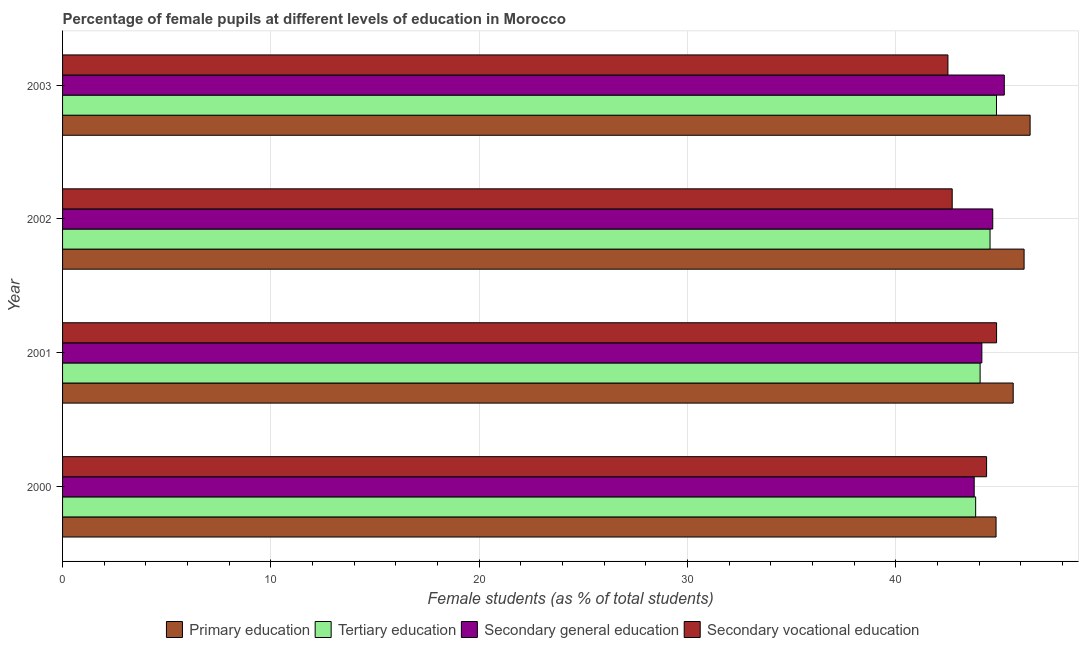How many different coloured bars are there?
Make the answer very short. 4. Are the number of bars on each tick of the Y-axis equal?
Ensure brevity in your answer.  Yes. How many bars are there on the 3rd tick from the top?
Make the answer very short. 4. How many bars are there on the 4th tick from the bottom?
Provide a succinct answer. 4. What is the label of the 2nd group of bars from the top?
Provide a succinct answer. 2002. In how many cases, is the number of bars for a given year not equal to the number of legend labels?
Give a very brief answer. 0. What is the percentage of female students in tertiary education in 2000?
Your answer should be compact. 43.83. Across all years, what is the maximum percentage of female students in tertiary education?
Make the answer very short. 44.83. Across all years, what is the minimum percentage of female students in secondary education?
Give a very brief answer. 43.76. In which year was the percentage of female students in secondary vocational education maximum?
Give a very brief answer. 2001. What is the total percentage of female students in primary education in the graph?
Your answer should be very brief. 183.03. What is the difference between the percentage of female students in primary education in 2000 and that in 2003?
Offer a terse response. -1.63. What is the difference between the percentage of female students in tertiary education in 2001 and the percentage of female students in primary education in 2002?
Give a very brief answer. -2.11. What is the average percentage of female students in tertiary education per year?
Offer a terse response. 44.3. In the year 2003, what is the difference between the percentage of female students in primary education and percentage of female students in secondary vocational education?
Your answer should be compact. 3.94. In how many years, is the percentage of female students in secondary vocational education greater than 42 %?
Offer a terse response. 4. What is the ratio of the percentage of female students in secondary education in 2000 to that in 2001?
Give a very brief answer. 0.99. Is the percentage of female students in tertiary education in 2001 less than that in 2003?
Your answer should be very brief. Yes. What is the difference between the highest and the second highest percentage of female students in primary education?
Keep it short and to the point. 0.29. Is it the case that in every year, the sum of the percentage of female students in secondary vocational education and percentage of female students in primary education is greater than the sum of percentage of female students in tertiary education and percentage of female students in secondary education?
Make the answer very short. No. What does the 3rd bar from the top in 2003 represents?
Give a very brief answer. Tertiary education. What does the 4th bar from the bottom in 2000 represents?
Offer a very short reply. Secondary vocational education. How many bars are there?
Provide a short and direct response. 16. Are all the bars in the graph horizontal?
Offer a very short reply. Yes. What is the difference between two consecutive major ticks on the X-axis?
Keep it short and to the point. 10. Does the graph contain any zero values?
Make the answer very short. No. Does the graph contain grids?
Your response must be concise. Yes. How many legend labels are there?
Offer a very short reply. 4. What is the title of the graph?
Your response must be concise. Percentage of female pupils at different levels of education in Morocco. What is the label or title of the X-axis?
Give a very brief answer. Female students (as % of total students). What is the label or title of the Y-axis?
Offer a very short reply. Year. What is the Female students (as % of total students) of Primary education in 2000?
Your answer should be very brief. 44.81. What is the Female students (as % of total students) of Tertiary education in 2000?
Offer a very short reply. 43.83. What is the Female students (as % of total students) in Secondary general education in 2000?
Offer a very short reply. 43.76. What is the Female students (as % of total students) of Secondary vocational education in 2000?
Your response must be concise. 44.35. What is the Female students (as % of total students) in Primary education in 2001?
Give a very brief answer. 45.63. What is the Female students (as % of total students) of Tertiary education in 2001?
Ensure brevity in your answer.  44.04. What is the Female students (as % of total students) in Secondary general education in 2001?
Give a very brief answer. 44.12. What is the Female students (as % of total students) in Secondary vocational education in 2001?
Provide a short and direct response. 44.83. What is the Female students (as % of total students) of Primary education in 2002?
Provide a short and direct response. 46.15. What is the Female students (as % of total students) of Tertiary education in 2002?
Your answer should be very brief. 44.52. What is the Female students (as % of total students) of Secondary general education in 2002?
Offer a very short reply. 44.65. What is the Female students (as % of total students) of Secondary vocational education in 2002?
Ensure brevity in your answer.  42.7. What is the Female students (as % of total students) of Primary education in 2003?
Make the answer very short. 46.44. What is the Female students (as % of total students) of Tertiary education in 2003?
Provide a succinct answer. 44.83. What is the Female students (as % of total students) of Secondary general education in 2003?
Provide a short and direct response. 45.2. What is the Female students (as % of total students) of Secondary vocational education in 2003?
Ensure brevity in your answer.  42.5. Across all years, what is the maximum Female students (as % of total students) of Primary education?
Provide a short and direct response. 46.44. Across all years, what is the maximum Female students (as % of total students) in Tertiary education?
Keep it short and to the point. 44.83. Across all years, what is the maximum Female students (as % of total students) of Secondary general education?
Your answer should be compact. 45.2. Across all years, what is the maximum Female students (as % of total students) in Secondary vocational education?
Offer a terse response. 44.83. Across all years, what is the minimum Female students (as % of total students) of Primary education?
Keep it short and to the point. 44.81. Across all years, what is the minimum Female students (as % of total students) of Tertiary education?
Keep it short and to the point. 43.83. Across all years, what is the minimum Female students (as % of total students) of Secondary general education?
Your answer should be very brief. 43.76. Across all years, what is the minimum Female students (as % of total students) in Secondary vocational education?
Offer a very short reply. 42.5. What is the total Female students (as % of total students) of Primary education in the graph?
Provide a succinct answer. 183.03. What is the total Female students (as % of total students) of Tertiary education in the graph?
Your answer should be very brief. 177.21. What is the total Female students (as % of total students) of Secondary general education in the graph?
Provide a short and direct response. 177.73. What is the total Female students (as % of total students) of Secondary vocational education in the graph?
Your response must be concise. 174.38. What is the difference between the Female students (as % of total students) in Primary education in 2000 and that in 2001?
Ensure brevity in your answer.  -0.82. What is the difference between the Female students (as % of total students) in Tertiary education in 2000 and that in 2001?
Make the answer very short. -0.21. What is the difference between the Female students (as % of total students) of Secondary general education in 2000 and that in 2001?
Your answer should be very brief. -0.37. What is the difference between the Female students (as % of total students) of Secondary vocational education in 2000 and that in 2001?
Your answer should be compact. -0.48. What is the difference between the Female students (as % of total students) in Primary education in 2000 and that in 2002?
Keep it short and to the point. -1.34. What is the difference between the Female students (as % of total students) of Tertiary education in 2000 and that in 2002?
Your answer should be very brief. -0.69. What is the difference between the Female students (as % of total students) of Secondary general education in 2000 and that in 2002?
Offer a very short reply. -0.89. What is the difference between the Female students (as % of total students) of Secondary vocational education in 2000 and that in 2002?
Make the answer very short. 1.65. What is the difference between the Female students (as % of total students) of Primary education in 2000 and that in 2003?
Provide a short and direct response. -1.63. What is the difference between the Female students (as % of total students) of Tertiary education in 2000 and that in 2003?
Keep it short and to the point. -1. What is the difference between the Female students (as % of total students) in Secondary general education in 2000 and that in 2003?
Give a very brief answer. -1.44. What is the difference between the Female students (as % of total students) of Secondary vocational education in 2000 and that in 2003?
Keep it short and to the point. 1.86. What is the difference between the Female students (as % of total students) of Primary education in 2001 and that in 2002?
Provide a short and direct response. -0.52. What is the difference between the Female students (as % of total students) of Tertiary education in 2001 and that in 2002?
Offer a terse response. -0.48. What is the difference between the Female students (as % of total students) of Secondary general education in 2001 and that in 2002?
Provide a short and direct response. -0.52. What is the difference between the Female students (as % of total students) of Secondary vocational education in 2001 and that in 2002?
Ensure brevity in your answer.  2.13. What is the difference between the Female students (as % of total students) of Primary education in 2001 and that in 2003?
Make the answer very short. -0.81. What is the difference between the Female students (as % of total students) of Tertiary education in 2001 and that in 2003?
Provide a short and direct response. -0.79. What is the difference between the Female students (as % of total students) in Secondary general education in 2001 and that in 2003?
Provide a short and direct response. -1.08. What is the difference between the Female students (as % of total students) of Secondary vocational education in 2001 and that in 2003?
Give a very brief answer. 2.33. What is the difference between the Female students (as % of total students) of Primary education in 2002 and that in 2003?
Your answer should be very brief. -0.29. What is the difference between the Female students (as % of total students) in Tertiary education in 2002 and that in 2003?
Offer a very short reply. -0.31. What is the difference between the Female students (as % of total students) in Secondary general education in 2002 and that in 2003?
Ensure brevity in your answer.  -0.55. What is the difference between the Female students (as % of total students) of Secondary vocational education in 2002 and that in 2003?
Offer a very short reply. 0.2. What is the difference between the Female students (as % of total students) in Primary education in 2000 and the Female students (as % of total students) in Tertiary education in 2001?
Offer a very short reply. 0.77. What is the difference between the Female students (as % of total students) in Primary education in 2000 and the Female students (as % of total students) in Secondary general education in 2001?
Ensure brevity in your answer.  0.68. What is the difference between the Female students (as % of total students) in Primary education in 2000 and the Female students (as % of total students) in Secondary vocational education in 2001?
Make the answer very short. -0.02. What is the difference between the Female students (as % of total students) in Tertiary education in 2000 and the Female students (as % of total students) in Secondary general education in 2001?
Keep it short and to the point. -0.3. What is the difference between the Female students (as % of total students) in Tertiary education in 2000 and the Female students (as % of total students) in Secondary vocational education in 2001?
Give a very brief answer. -1. What is the difference between the Female students (as % of total students) in Secondary general education in 2000 and the Female students (as % of total students) in Secondary vocational education in 2001?
Ensure brevity in your answer.  -1.07. What is the difference between the Female students (as % of total students) in Primary education in 2000 and the Female students (as % of total students) in Tertiary education in 2002?
Offer a terse response. 0.29. What is the difference between the Female students (as % of total students) in Primary education in 2000 and the Female students (as % of total students) in Secondary general education in 2002?
Provide a short and direct response. 0.16. What is the difference between the Female students (as % of total students) in Primary education in 2000 and the Female students (as % of total students) in Secondary vocational education in 2002?
Offer a terse response. 2.11. What is the difference between the Female students (as % of total students) of Tertiary education in 2000 and the Female students (as % of total students) of Secondary general education in 2002?
Your response must be concise. -0.82. What is the difference between the Female students (as % of total students) in Tertiary education in 2000 and the Female students (as % of total students) in Secondary vocational education in 2002?
Your answer should be very brief. 1.13. What is the difference between the Female students (as % of total students) of Secondary general education in 2000 and the Female students (as % of total students) of Secondary vocational education in 2002?
Offer a very short reply. 1.06. What is the difference between the Female students (as % of total students) of Primary education in 2000 and the Female students (as % of total students) of Tertiary education in 2003?
Offer a terse response. -0.02. What is the difference between the Female students (as % of total students) of Primary education in 2000 and the Female students (as % of total students) of Secondary general education in 2003?
Your answer should be compact. -0.4. What is the difference between the Female students (as % of total students) in Primary education in 2000 and the Female students (as % of total students) in Secondary vocational education in 2003?
Make the answer very short. 2.31. What is the difference between the Female students (as % of total students) in Tertiary education in 2000 and the Female students (as % of total students) in Secondary general education in 2003?
Provide a short and direct response. -1.37. What is the difference between the Female students (as % of total students) in Tertiary education in 2000 and the Female students (as % of total students) in Secondary vocational education in 2003?
Provide a short and direct response. 1.33. What is the difference between the Female students (as % of total students) of Secondary general education in 2000 and the Female students (as % of total students) of Secondary vocational education in 2003?
Your response must be concise. 1.26. What is the difference between the Female students (as % of total students) of Primary education in 2001 and the Female students (as % of total students) of Tertiary education in 2002?
Your response must be concise. 1.11. What is the difference between the Female students (as % of total students) of Primary education in 2001 and the Female students (as % of total students) of Secondary general education in 2002?
Your answer should be very brief. 0.98. What is the difference between the Female students (as % of total students) of Primary education in 2001 and the Female students (as % of total students) of Secondary vocational education in 2002?
Offer a very short reply. 2.93. What is the difference between the Female students (as % of total students) in Tertiary education in 2001 and the Female students (as % of total students) in Secondary general education in 2002?
Your response must be concise. -0.61. What is the difference between the Female students (as % of total students) in Tertiary education in 2001 and the Female students (as % of total students) in Secondary vocational education in 2002?
Offer a very short reply. 1.34. What is the difference between the Female students (as % of total students) in Secondary general education in 2001 and the Female students (as % of total students) in Secondary vocational education in 2002?
Your response must be concise. 1.42. What is the difference between the Female students (as % of total students) of Primary education in 2001 and the Female students (as % of total students) of Tertiary education in 2003?
Your answer should be compact. 0.8. What is the difference between the Female students (as % of total students) of Primary education in 2001 and the Female students (as % of total students) of Secondary general education in 2003?
Keep it short and to the point. 0.43. What is the difference between the Female students (as % of total students) in Primary education in 2001 and the Female students (as % of total students) in Secondary vocational education in 2003?
Keep it short and to the point. 3.13. What is the difference between the Female students (as % of total students) of Tertiary education in 2001 and the Female students (as % of total students) of Secondary general education in 2003?
Offer a terse response. -1.16. What is the difference between the Female students (as % of total students) of Tertiary education in 2001 and the Female students (as % of total students) of Secondary vocational education in 2003?
Make the answer very short. 1.54. What is the difference between the Female students (as % of total students) of Secondary general education in 2001 and the Female students (as % of total students) of Secondary vocational education in 2003?
Provide a succinct answer. 1.63. What is the difference between the Female students (as % of total students) of Primary education in 2002 and the Female students (as % of total students) of Tertiary education in 2003?
Your response must be concise. 1.32. What is the difference between the Female students (as % of total students) of Primary education in 2002 and the Female students (as % of total students) of Secondary general education in 2003?
Provide a short and direct response. 0.95. What is the difference between the Female students (as % of total students) of Primary education in 2002 and the Female students (as % of total students) of Secondary vocational education in 2003?
Make the answer very short. 3.65. What is the difference between the Female students (as % of total students) in Tertiary education in 2002 and the Female students (as % of total students) in Secondary general education in 2003?
Provide a succinct answer. -0.68. What is the difference between the Female students (as % of total students) in Tertiary education in 2002 and the Female students (as % of total students) in Secondary vocational education in 2003?
Your answer should be very brief. 2.02. What is the difference between the Female students (as % of total students) of Secondary general education in 2002 and the Female students (as % of total students) of Secondary vocational education in 2003?
Offer a terse response. 2.15. What is the average Female students (as % of total students) of Primary education per year?
Make the answer very short. 45.76. What is the average Female students (as % of total students) of Tertiary education per year?
Your response must be concise. 44.3. What is the average Female students (as % of total students) of Secondary general education per year?
Give a very brief answer. 44.43. What is the average Female students (as % of total students) of Secondary vocational education per year?
Give a very brief answer. 43.59. In the year 2000, what is the difference between the Female students (as % of total students) of Primary education and Female students (as % of total students) of Tertiary education?
Ensure brevity in your answer.  0.98. In the year 2000, what is the difference between the Female students (as % of total students) in Primary education and Female students (as % of total students) in Secondary general education?
Provide a short and direct response. 1.05. In the year 2000, what is the difference between the Female students (as % of total students) of Primary education and Female students (as % of total students) of Secondary vocational education?
Provide a short and direct response. 0.45. In the year 2000, what is the difference between the Female students (as % of total students) of Tertiary education and Female students (as % of total students) of Secondary general education?
Give a very brief answer. 0.07. In the year 2000, what is the difference between the Female students (as % of total students) in Tertiary education and Female students (as % of total students) in Secondary vocational education?
Ensure brevity in your answer.  -0.52. In the year 2000, what is the difference between the Female students (as % of total students) in Secondary general education and Female students (as % of total students) in Secondary vocational education?
Your answer should be very brief. -0.59. In the year 2001, what is the difference between the Female students (as % of total students) in Primary education and Female students (as % of total students) in Tertiary education?
Your answer should be very brief. 1.59. In the year 2001, what is the difference between the Female students (as % of total students) of Primary education and Female students (as % of total students) of Secondary general education?
Offer a terse response. 1.5. In the year 2001, what is the difference between the Female students (as % of total students) of Primary education and Female students (as % of total students) of Secondary vocational education?
Your answer should be compact. 0.8. In the year 2001, what is the difference between the Female students (as % of total students) of Tertiary education and Female students (as % of total students) of Secondary general education?
Provide a short and direct response. -0.08. In the year 2001, what is the difference between the Female students (as % of total students) in Tertiary education and Female students (as % of total students) in Secondary vocational education?
Keep it short and to the point. -0.79. In the year 2001, what is the difference between the Female students (as % of total students) in Secondary general education and Female students (as % of total students) in Secondary vocational education?
Provide a short and direct response. -0.71. In the year 2002, what is the difference between the Female students (as % of total students) in Primary education and Female students (as % of total students) in Tertiary education?
Offer a very short reply. 1.63. In the year 2002, what is the difference between the Female students (as % of total students) of Primary education and Female students (as % of total students) of Secondary general education?
Keep it short and to the point. 1.5. In the year 2002, what is the difference between the Female students (as % of total students) in Primary education and Female students (as % of total students) in Secondary vocational education?
Offer a terse response. 3.45. In the year 2002, what is the difference between the Female students (as % of total students) in Tertiary education and Female students (as % of total students) in Secondary general education?
Your answer should be compact. -0.13. In the year 2002, what is the difference between the Female students (as % of total students) of Tertiary education and Female students (as % of total students) of Secondary vocational education?
Give a very brief answer. 1.82. In the year 2002, what is the difference between the Female students (as % of total students) of Secondary general education and Female students (as % of total students) of Secondary vocational education?
Provide a succinct answer. 1.95. In the year 2003, what is the difference between the Female students (as % of total students) in Primary education and Female students (as % of total students) in Tertiary education?
Give a very brief answer. 1.61. In the year 2003, what is the difference between the Female students (as % of total students) of Primary education and Female students (as % of total students) of Secondary general education?
Give a very brief answer. 1.24. In the year 2003, what is the difference between the Female students (as % of total students) in Primary education and Female students (as % of total students) in Secondary vocational education?
Provide a succinct answer. 3.94. In the year 2003, what is the difference between the Female students (as % of total students) of Tertiary education and Female students (as % of total students) of Secondary general education?
Give a very brief answer. -0.37. In the year 2003, what is the difference between the Female students (as % of total students) in Tertiary education and Female students (as % of total students) in Secondary vocational education?
Give a very brief answer. 2.33. In the year 2003, what is the difference between the Female students (as % of total students) in Secondary general education and Female students (as % of total students) in Secondary vocational education?
Make the answer very short. 2.71. What is the ratio of the Female students (as % of total students) of Primary education in 2000 to that in 2001?
Your response must be concise. 0.98. What is the ratio of the Female students (as % of total students) of Secondary general education in 2000 to that in 2001?
Offer a terse response. 0.99. What is the ratio of the Female students (as % of total students) in Secondary vocational education in 2000 to that in 2001?
Offer a very short reply. 0.99. What is the ratio of the Female students (as % of total students) of Primary education in 2000 to that in 2002?
Your answer should be very brief. 0.97. What is the ratio of the Female students (as % of total students) of Tertiary education in 2000 to that in 2002?
Your answer should be very brief. 0.98. What is the ratio of the Female students (as % of total students) in Secondary general education in 2000 to that in 2002?
Your answer should be compact. 0.98. What is the ratio of the Female students (as % of total students) in Secondary vocational education in 2000 to that in 2002?
Make the answer very short. 1.04. What is the ratio of the Female students (as % of total students) in Primary education in 2000 to that in 2003?
Your answer should be compact. 0.96. What is the ratio of the Female students (as % of total students) of Tertiary education in 2000 to that in 2003?
Ensure brevity in your answer.  0.98. What is the ratio of the Female students (as % of total students) of Secondary general education in 2000 to that in 2003?
Ensure brevity in your answer.  0.97. What is the ratio of the Female students (as % of total students) of Secondary vocational education in 2000 to that in 2003?
Offer a terse response. 1.04. What is the ratio of the Female students (as % of total students) in Primary education in 2001 to that in 2002?
Provide a short and direct response. 0.99. What is the ratio of the Female students (as % of total students) of Tertiary education in 2001 to that in 2002?
Offer a terse response. 0.99. What is the ratio of the Female students (as % of total students) of Secondary general education in 2001 to that in 2002?
Offer a very short reply. 0.99. What is the ratio of the Female students (as % of total students) in Secondary vocational education in 2001 to that in 2002?
Offer a terse response. 1.05. What is the ratio of the Female students (as % of total students) in Primary education in 2001 to that in 2003?
Your answer should be compact. 0.98. What is the ratio of the Female students (as % of total students) in Tertiary education in 2001 to that in 2003?
Offer a terse response. 0.98. What is the ratio of the Female students (as % of total students) of Secondary general education in 2001 to that in 2003?
Keep it short and to the point. 0.98. What is the ratio of the Female students (as % of total students) in Secondary vocational education in 2001 to that in 2003?
Provide a succinct answer. 1.05. What is the ratio of the Female students (as % of total students) of Tertiary education in 2002 to that in 2003?
Provide a succinct answer. 0.99. What is the ratio of the Female students (as % of total students) of Secondary general education in 2002 to that in 2003?
Ensure brevity in your answer.  0.99. What is the ratio of the Female students (as % of total students) in Secondary vocational education in 2002 to that in 2003?
Provide a short and direct response. 1. What is the difference between the highest and the second highest Female students (as % of total students) of Primary education?
Keep it short and to the point. 0.29. What is the difference between the highest and the second highest Female students (as % of total students) of Tertiary education?
Offer a terse response. 0.31. What is the difference between the highest and the second highest Female students (as % of total students) in Secondary general education?
Make the answer very short. 0.55. What is the difference between the highest and the second highest Female students (as % of total students) of Secondary vocational education?
Ensure brevity in your answer.  0.48. What is the difference between the highest and the lowest Female students (as % of total students) of Primary education?
Offer a terse response. 1.63. What is the difference between the highest and the lowest Female students (as % of total students) in Tertiary education?
Provide a succinct answer. 1. What is the difference between the highest and the lowest Female students (as % of total students) of Secondary general education?
Your answer should be very brief. 1.44. What is the difference between the highest and the lowest Female students (as % of total students) in Secondary vocational education?
Provide a short and direct response. 2.33. 